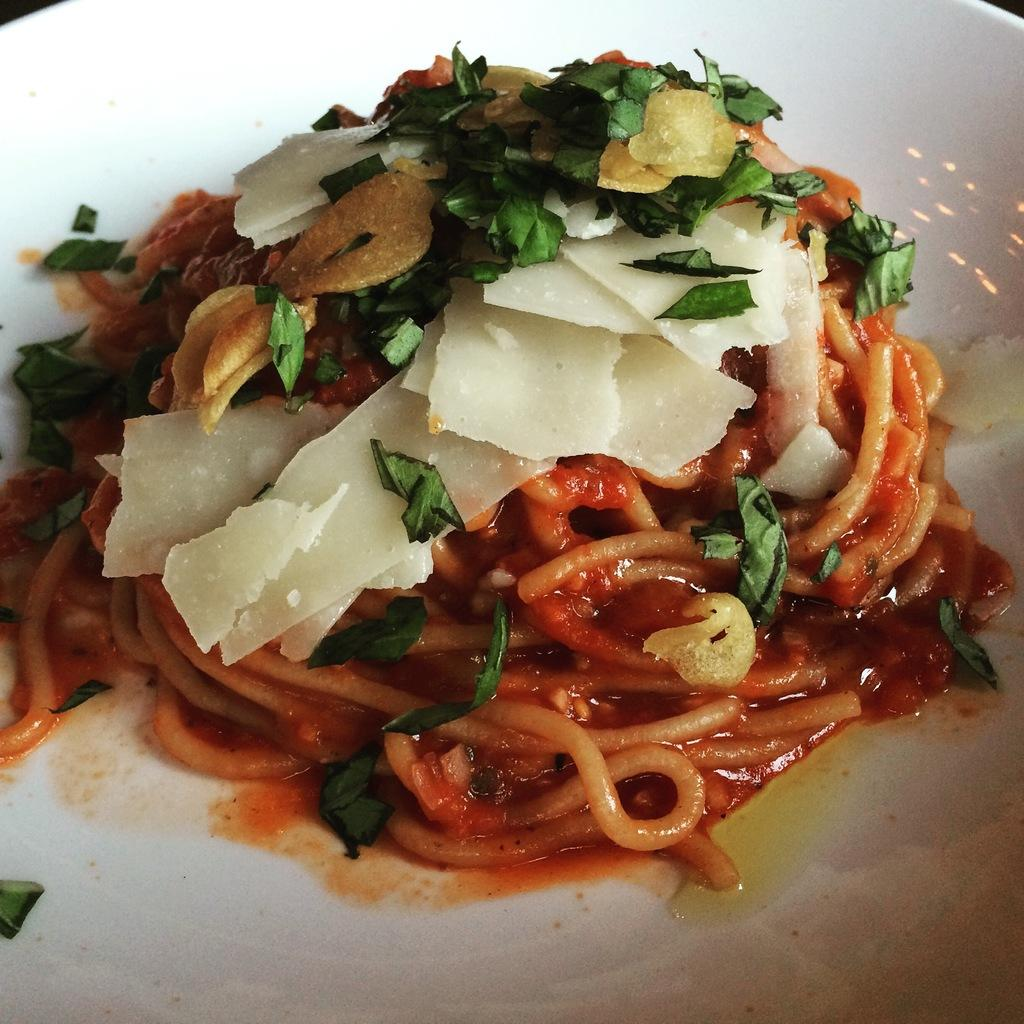What is on the plate that is visible in the image? There is a plate containing food in the image. What type of border can be seen around the plate in the image? There is no mention of a border around the plate in the provided facts, so it cannot be determined from the image. 